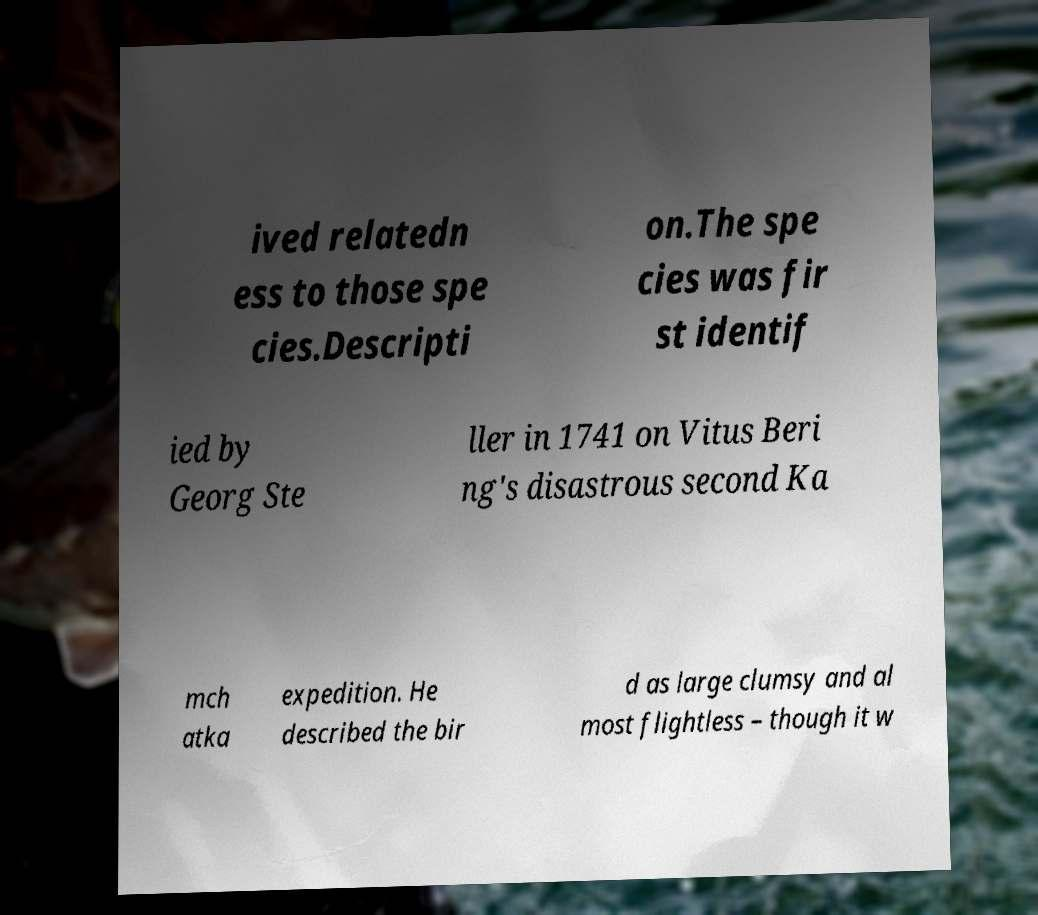Can you read and provide the text displayed in the image?This photo seems to have some interesting text. Can you extract and type it out for me? ived relatedn ess to those spe cies.Descripti on.The spe cies was fir st identif ied by Georg Ste ller in 1741 on Vitus Beri ng's disastrous second Ka mch atka expedition. He described the bir d as large clumsy and al most flightless – though it w 